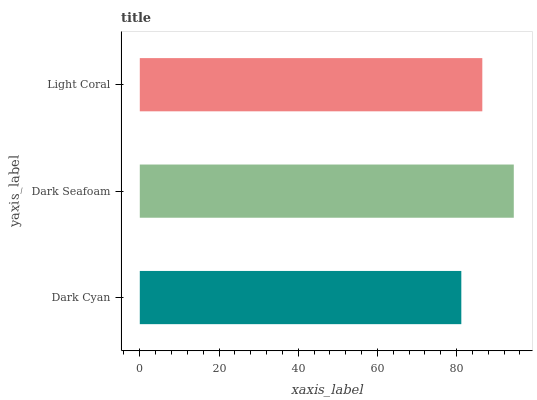Is Dark Cyan the minimum?
Answer yes or no. Yes. Is Dark Seafoam the maximum?
Answer yes or no. Yes. Is Light Coral the minimum?
Answer yes or no. No. Is Light Coral the maximum?
Answer yes or no. No. Is Dark Seafoam greater than Light Coral?
Answer yes or no. Yes. Is Light Coral less than Dark Seafoam?
Answer yes or no. Yes. Is Light Coral greater than Dark Seafoam?
Answer yes or no. No. Is Dark Seafoam less than Light Coral?
Answer yes or no. No. Is Light Coral the high median?
Answer yes or no. Yes. Is Light Coral the low median?
Answer yes or no. Yes. Is Dark Seafoam the high median?
Answer yes or no. No. Is Dark Cyan the low median?
Answer yes or no. No. 